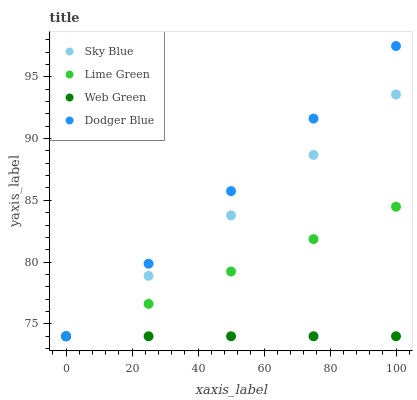Does Web Green have the minimum area under the curve?
Answer yes or no. Yes. Does Dodger Blue have the maximum area under the curve?
Answer yes or no. Yes. Does Lime Green have the minimum area under the curve?
Answer yes or no. No. Does Lime Green have the maximum area under the curve?
Answer yes or no. No. Is Sky Blue the smoothest?
Answer yes or no. Yes. Is Dodger Blue the roughest?
Answer yes or no. Yes. Is Lime Green the smoothest?
Answer yes or no. No. Is Web Green the roughest?
Answer yes or no. No. Does Sky Blue have the lowest value?
Answer yes or no. Yes. Does Dodger Blue have the highest value?
Answer yes or no. Yes. Does Lime Green have the highest value?
Answer yes or no. No. Does Lime Green intersect Web Green?
Answer yes or no. Yes. Is Lime Green less than Web Green?
Answer yes or no. No. Is Lime Green greater than Web Green?
Answer yes or no. No. 